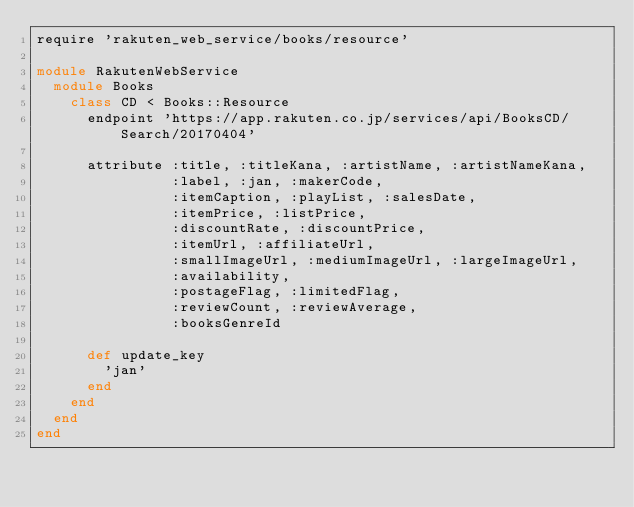<code> <loc_0><loc_0><loc_500><loc_500><_Ruby_>require 'rakuten_web_service/books/resource'

module RakutenWebService
  module Books
    class CD < Books::Resource
      endpoint 'https://app.rakuten.co.jp/services/api/BooksCD/Search/20170404'

      attribute :title, :titleKana, :artistName, :artistNameKana,
                :label, :jan, :makerCode,
                :itemCaption, :playList, :salesDate,
                :itemPrice, :listPrice,
                :discountRate, :discountPrice,
                :itemUrl, :affiliateUrl,
                :smallImageUrl, :mediumImageUrl, :largeImageUrl,
                :availability,
                :postageFlag, :limitedFlag,
                :reviewCount, :reviewAverage,
                :booksGenreId

      def update_key
        'jan'
      end
    end
  end
end
</code> 